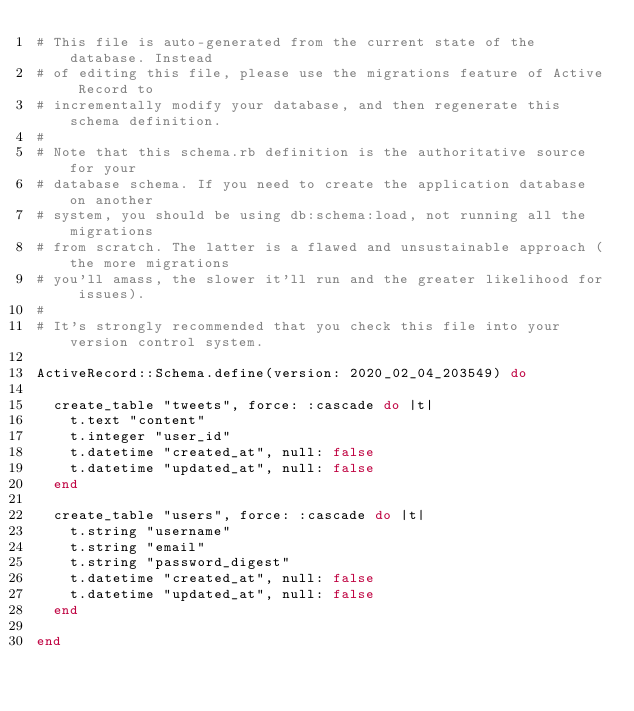Convert code to text. <code><loc_0><loc_0><loc_500><loc_500><_Ruby_># This file is auto-generated from the current state of the database. Instead
# of editing this file, please use the migrations feature of Active Record to
# incrementally modify your database, and then regenerate this schema definition.
#
# Note that this schema.rb definition is the authoritative source for your
# database schema. If you need to create the application database on another
# system, you should be using db:schema:load, not running all the migrations
# from scratch. The latter is a flawed and unsustainable approach (the more migrations
# you'll amass, the slower it'll run and the greater likelihood for issues).
#
# It's strongly recommended that you check this file into your version control system.

ActiveRecord::Schema.define(version: 2020_02_04_203549) do

  create_table "tweets", force: :cascade do |t|
    t.text "content"
    t.integer "user_id"
    t.datetime "created_at", null: false
    t.datetime "updated_at", null: false
  end

  create_table "users", force: :cascade do |t|
    t.string "username"
    t.string "email"
    t.string "password_digest"
    t.datetime "created_at", null: false
    t.datetime "updated_at", null: false
  end

end
</code> 